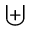Convert formula to latex. <formula><loc_0><loc_0><loc_500><loc_500>\uplus</formula> 